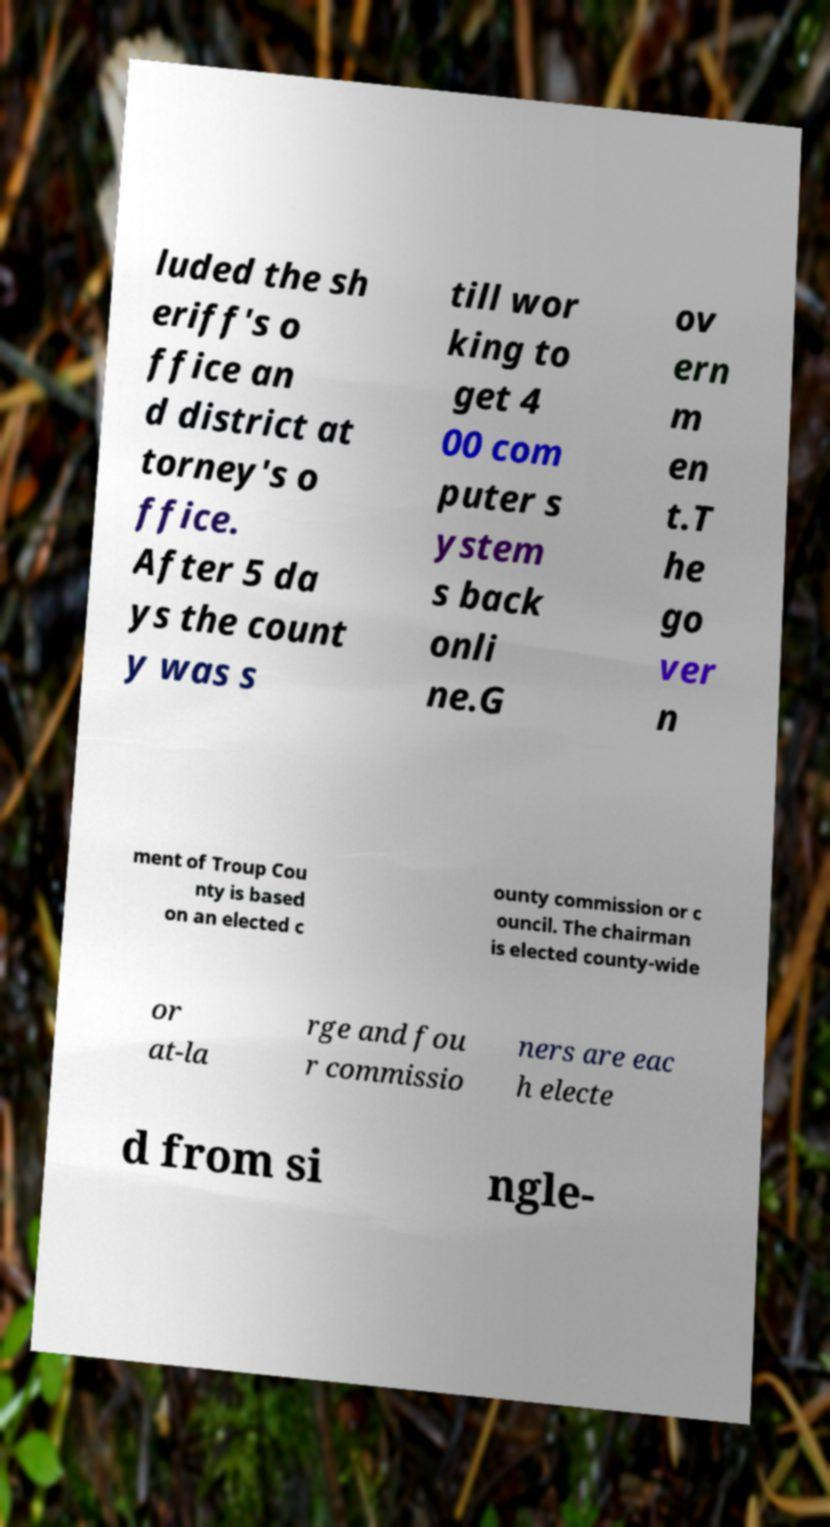For documentation purposes, I need the text within this image transcribed. Could you provide that? luded the sh eriff's o ffice an d district at torney's o ffice. After 5 da ys the count y was s till wor king to get 4 00 com puter s ystem s back onli ne.G ov ern m en t.T he go ver n ment of Troup Cou nty is based on an elected c ounty commission or c ouncil. The chairman is elected county-wide or at-la rge and fou r commissio ners are eac h electe d from si ngle- 